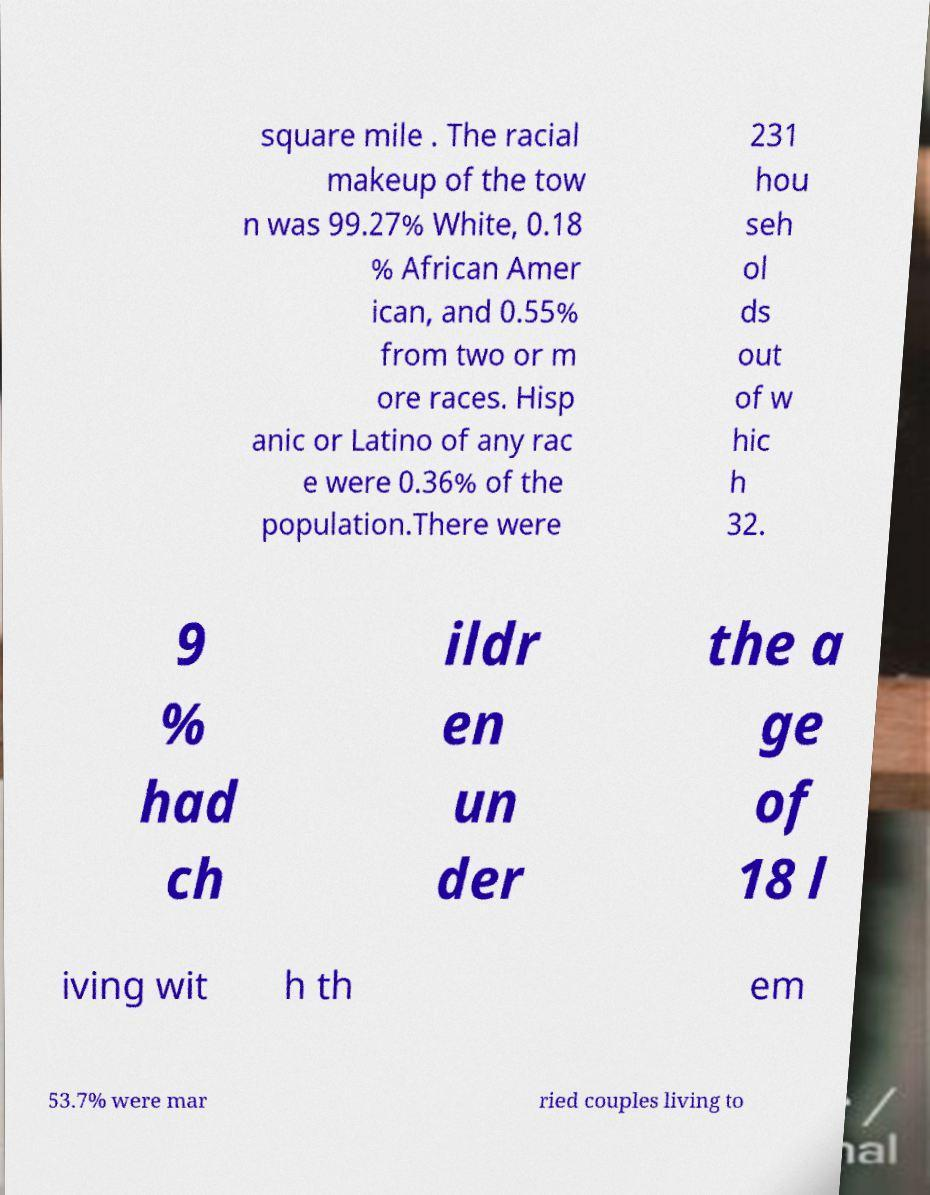There's text embedded in this image that I need extracted. Can you transcribe it verbatim? square mile . The racial makeup of the tow n was 99.27% White, 0.18 % African Amer ican, and 0.55% from two or m ore races. Hisp anic or Latino of any rac e were 0.36% of the population.There were 231 hou seh ol ds out of w hic h 32. 9 % had ch ildr en un der the a ge of 18 l iving wit h th em 53.7% were mar ried couples living to 